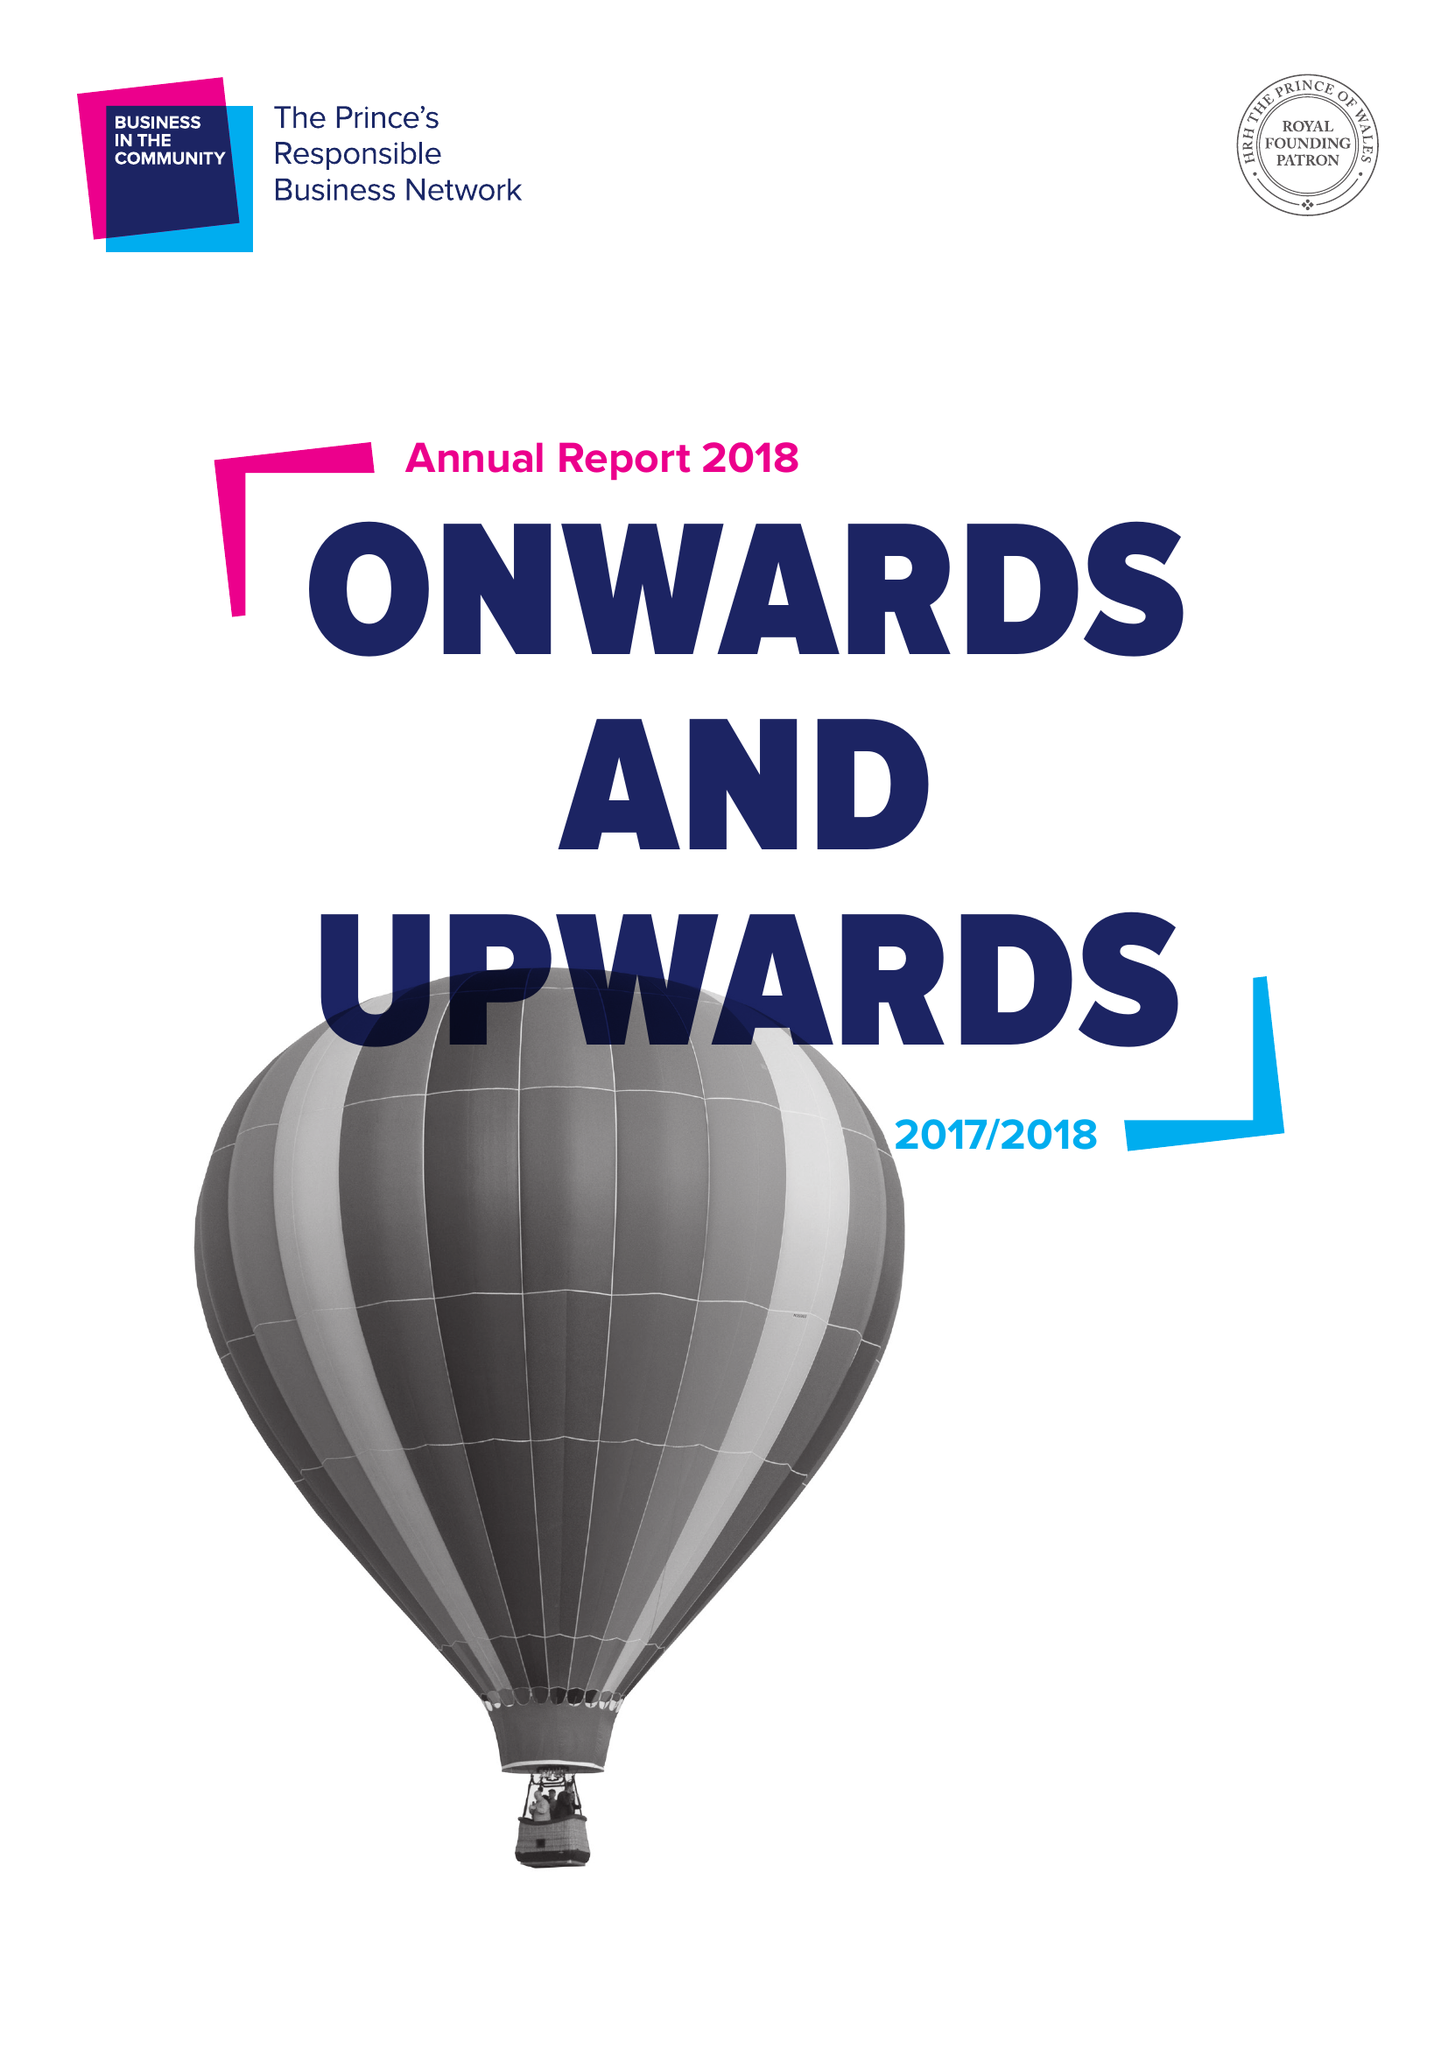What is the value for the spending_annually_in_british_pounds?
Answer the question using a single word or phrase. 21425386.00 